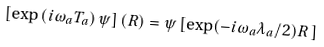Convert formula to latex. <formula><loc_0><loc_0><loc_500><loc_500>\left [ \exp \left ( i \omega _ { a } T _ { a } \right ) \psi \right ] ( R ) = \psi \left [ \exp ( - i \omega _ { a } \lambda _ { a } / 2 ) R \, \right ]</formula> 